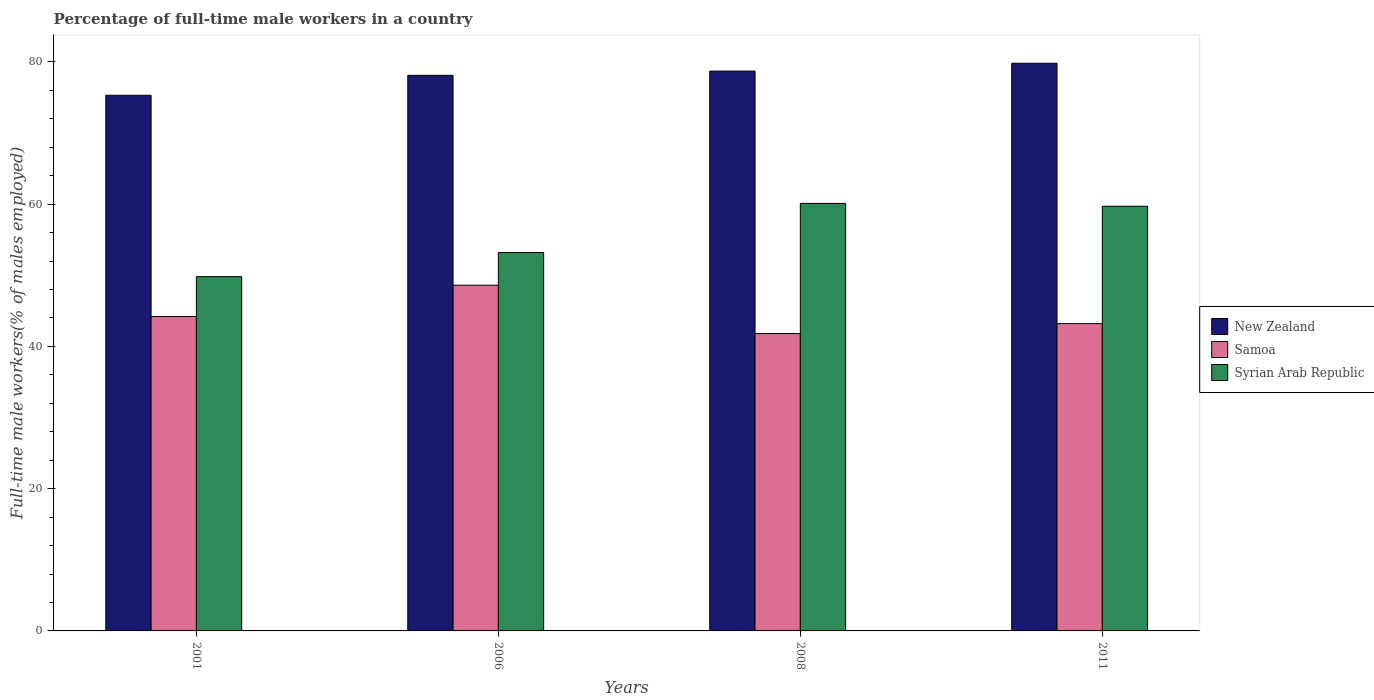Are the number of bars per tick equal to the number of legend labels?
Your answer should be very brief. Yes. Are the number of bars on each tick of the X-axis equal?
Offer a very short reply. Yes. How many bars are there on the 2nd tick from the right?
Ensure brevity in your answer.  3. What is the label of the 4th group of bars from the left?
Ensure brevity in your answer.  2011. What is the percentage of full-time male workers in New Zealand in 2011?
Provide a succinct answer. 79.8. Across all years, what is the maximum percentage of full-time male workers in New Zealand?
Offer a very short reply. 79.8. Across all years, what is the minimum percentage of full-time male workers in New Zealand?
Ensure brevity in your answer.  75.3. In which year was the percentage of full-time male workers in Syrian Arab Republic maximum?
Give a very brief answer. 2008. In which year was the percentage of full-time male workers in Syrian Arab Republic minimum?
Provide a short and direct response. 2001. What is the total percentage of full-time male workers in Syrian Arab Republic in the graph?
Offer a very short reply. 222.8. What is the difference between the percentage of full-time male workers in New Zealand in 2001 and that in 2006?
Make the answer very short. -2.8. What is the difference between the percentage of full-time male workers in Samoa in 2008 and the percentage of full-time male workers in New Zealand in 2011?
Ensure brevity in your answer.  -38. What is the average percentage of full-time male workers in Syrian Arab Republic per year?
Your response must be concise. 55.7. In the year 2001, what is the difference between the percentage of full-time male workers in Samoa and percentage of full-time male workers in New Zealand?
Your response must be concise. -31.1. In how many years, is the percentage of full-time male workers in Samoa greater than 32 %?
Your answer should be compact. 4. What is the ratio of the percentage of full-time male workers in New Zealand in 2001 to that in 2008?
Your response must be concise. 0.96. Is the difference between the percentage of full-time male workers in Samoa in 2006 and 2008 greater than the difference between the percentage of full-time male workers in New Zealand in 2006 and 2008?
Keep it short and to the point. Yes. What is the difference between the highest and the second highest percentage of full-time male workers in Syrian Arab Republic?
Provide a short and direct response. 0.4. What is the difference between the highest and the lowest percentage of full-time male workers in New Zealand?
Your answer should be very brief. 4.5. Is the sum of the percentage of full-time male workers in Syrian Arab Republic in 2001 and 2011 greater than the maximum percentage of full-time male workers in Samoa across all years?
Your answer should be compact. Yes. What does the 2nd bar from the left in 2008 represents?
Offer a terse response. Samoa. What does the 1st bar from the right in 2001 represents?
Offer a very short reply. Syrian Arab Republic. What is the difference between two consecutive major ticks on the Y-axis?
Your answer should be compact. 20. Are the values on the major ticks of Y-axis written in scientific E-notation?
Give a very brief answer. No. Does the graph contain grids?
Your answer should be very brief. No. Where does the legend appear in the graph?
Keep it short and to the point. Center right. How are the legend labels stacked?
Your answer should be compact. Vertical. What is the title of the graph?
Ensure brevity in your answer.  Percentage of full-time male workers in a country. What is the label or title of the X-axis?
Your response must be concise. Years. What is the label or title of the Y-axis?
Provide a succinct answer. Full-time male workers(% of males employed). What is the Full-time male workers(% of males employed) in New Zealand in 2001?
Give a very brief answer. 75.3. What is the Full-time male workers(% of males employed) in Samoa in 2001?
Provide a succinct answer. 44.2. What is the Full-time male workers(% of males employed) in Syrian Arab Republic in 2001?
Keep it short and to the point. 49.8. What is the Full-time male workers(% of males employed) of New Zealand in 2006?
Ensure brevity in your answer.  78.1. What is the Full-time male workers(% of males employed) in Samoa in 2006?
Offer a very short reply. 48.6. What is the Full-time male workers(% of males employed) in Syrian Arab Republic in 2006?
Provide a short and direct response. 53.2. What is the Full-time male workers(% of males employed) of New Zealand in 2008?
Keep it short and to the point. 78.7. What is the Full-time male workers(% of males employed) in Samoa in 2008?
Provide a succinct answer. 41.8. What is the Full-time male workers(% of males employed) of Syrian Arab Republic in 2008?
Make the answer very short. 60.1. What is the Full-time male workers(% of males employed) of New Zealand in 2011?
Give a very brief answer. 79.8. What is the Full-time male workers(% of males employed) of Samoa in 2011?
Provide a succinct answer. 43.2. What is the Full-time male workers(% of males employed) of Syrian Arab Republic in 2011?
Keep it short and to the point. 59.7. Across all years, what is the maximum Full-time male workers(% of males employed) in New Zealand?
Provide a short and direct response. 79.8. Across all years, what is the maximum Full-time male workers(% of males employed) in Samoa?
Make the answer very short. 48.6. Across all years, what is the maximum Full-time male workers(% of males employed) in Syrian Arab Republic?
Keep it short and to the point. 60.1. Across all years, what is the minimum Full-time male workers(% of males employed) in New Zealand?
Keep it short and to the point. 75.3. Across all years, what is the minimum Full-time male workers(% of males employed) in Samoa?
Provide a short and direct response. 41.8. Across all years, what is the minimum Full-time male workers(% of males employed) in Syrian Arab Republic?
Make the answer very short. 49.8. What is the total Full-time male workers(% of males employed) of New Zealand in the graph?
Your response must be concise. 311.9. What is the total Full-time male workers(% of males employed) of Samoa in the graph?
Offer a terse response. 177.8. What is the total Full-time male workers(% of males employed) in Syrian Arab Republic in the graph?
Provide a succinct answer. 222.8. What is the difference between the Full-time male workers(% of males employed) in Samoa in 2001 and that in 2006?
Your answer should be very brief. -4.4. What is the difference between the Full-time male workers(% of males employed) in Syrian Arab Republic in 2001 and that in 2006?
Offer a very short reply. -3.4. What is the difference between the Full-time male workers(% of males employed) of Samoa in 2001 and that in 2008?
Give a very brief answer. 2.4. What is the difference between the Full-time male workers(% of males employed) in Syrian Arab Republic in 2001 and that in 2011?
Keep it short and to the point. -9.9. What is the difference between the Full-time male workers(% of males employed) of Samoa in 2006 and that in 2008?
Your response must be concise. 6.8. What is the difference between the Full-time male workers(% of males employed) in Syrian Arab Republic in 2006 and that in 2008?
Your answer should be compact. -6.9. What is the difference between the Full-time male workers(% of males employed) in New Zealand in 2006 and that in 2011?
Provide a short and direct response. -1.7. What is the difference between the Full-time male workers(% of males employed) of Samoa in 2006 and that in 2011?
Your response must be concise. 5.4. What is the difference between the Full-time male workers(% of males employed) in Samoa in 2008 and that in 2011?
Offer a terse response. -1.4. What is the difference between the Full-time male workers(% of males employed) in New Zealand in 2001 and the Full-time male workers(% of males employed) in Samoa in 2006?
Ensure brevity in your answer.  26.7. What is the difference between the Full-time male workers(% of males employed) in New Zealand in 2001 and the Full-time male workers(% of males employed) in Syrian Arab Republic in 2006?
Keep it short and to the point. 22.1. What is the difference between the Full-time male workers(% of males employed) in Samoa in 2001 and the Full-time male workers(% of males employed) in Syrian Arab Republic in 2006?
Offer a terse response. -9. What is the difference between the Full-time male workers(% of males employed) of New Zealand in 2001 and the Full-time male workers(% of males employed) of Samoa in 2008?
Your answer should be compact. 33.5. What is the difference between the Full-time male workers(% of males employed) in Samoa in 2001 and the Full-time male workers(% of males employed) in Syrian Arab Republic in 2008?
Give a very brief answer. -15.9. What is the difference between the Full-time male workers(% of males employed) in New Zealand in 2001 and the Full-time male workers(% of males employed) in Samoa in 2011?
Ensure brevity in your answer.  32.1. What is the difference between the Full-time male workers(% of males employed) of Samoa in 2001 and the Full-time male workers(% of males employed) of Syrian Arab Republic in 2011?
Your response must be concise. -15.5. What is the difference between the Full-time male workers(% of males employed) in New Zealand in 2006 and the Full-time male workers(% of males employed) in Samoa in 2008?
Ensure brevity in your answer.  36.3. What is the difference between the Full-time male workers(% of males employed) of Samoa in 2006 and the Full-time male workers(% of males employed) of Syrian Arab Republic in 2008?
Your answer should be compact. -11.5. What is the difference between the Full-time male workers(% of males employed) in New Zealand in 2006 and the Full-time male workers(% of males employed) in Samoa in 2011?
Your answer should be compact. 34.9. What is the difference between the Full-time male workers(% of males employed) in Samoa in 2006 and the Full-time male workers(% of males employed) in Syrian Arab Republic in 2011?
Your response must be concise. -11.1. What is the difference between the Full-time male workers(% of males employed) in New Zealand in 2008 and the Full-time male workers(% of males employed) in Samoa in 2011?
Your response must be concise. 35.5. What is the difference between the Full-time male workers(% of males employed) in New Zealand in 2008 and the Full-time male workers(% of males employed) in Syrian Arab Republic in 2011?
Your answer should be very brief. 19. What is the difference between the Full-time male workers(% of males employed) in Samoa in 2008 and the Full-time male workers(% of males employed) in Syrian Arab Republic in 2011?
Your response must be concise. -17.9. What is the average Full-time male workers(% of males employed) in New Zealand per year?
Make the answer very short. 77.97. What is the average Full-time male workers(% of males employed) of Samoa per year?
Keep it short and to the point. 44.45. What is the average Full-time male workers(% of males employed) in Syrian Arab Republic per year?
Offer a very short reply. 55.7. In the year 2001, what is the difference between the Full-time male workers(% of males employed) of New Zealand and Full-time male workers(% of males employed) of Samoa?
Offer a very short reply. 31.1. In the year 2001, what is the difference between the Full-time male workers(% of males employed) of New Zealand and Full-time male workers(% of males employed) of Syrian Arab Republic?
Your answer should be very brief. 25.5. In the year 2001, what is the difference between the Full-time male workers(% of males employed) of Samoa and Full-time male workers(% of males employed) of Syrian Arab Republic?
Provide a succinct answer. -5.6. In the year 2006, what is the difference between the Full-time male workers(% of males employed) of New Zealand and Full-time male workers(% of males employed) of Samoa?
Your answer should be very brief. 29.5. In the year 2006, what is the difference between the Full-time male workers(% of males employed) in New Zealand and Full-time male workers(% of males employed) in Syrian Arab Republic?
Keep it short and to the point. 24.9. In the year 2006, what is the difference between the Full-time male workers(% of males employed) of Samoa and Full-time male workers(% of males employed) of Syrian Arab Republic?
Provide a short and direct response. -4.6. In the year 2008, what is the difference between the Full-time male workers(% of males employed) in New Zealand and Full-time male workers(% of males employed) in Samoa?
Ensure brevity in your answer.  36.9. In the year 2008, what is the difference between the Full-time male workers(% of males employed) in Samoa and Full-time male workers(% of males employed) in Syrian Arab Republic?
Give a very brief answer. -18.3. In the year 2011, what is the difference between the Full-time male workers(% of males employed) of New Zealand and Full-time male workers(% of males employed) of Samoa?
Provide a succinct answer. 36.6. In the year 2011, what is the difference between the Full-time male workers(% of males employed) in New Zealand and Full-time male workers(% of males employed) in Syrian Arab Republic?
Provide a succinct answer. 20.1. In the year 2011, what is the difference between the Full-time male workers(% of males employed) of Samoa and Full-time male workers(% of males employed) of Syrian Arab Republic?
Ensure brevity in your answer.  -16.5. What is the ratio of the Full-time male workers(% of males employed) in New Zealand in 2001 to that in 2006?
Make the answer very short. 0.96. What is the ratio of the Full-time male workers(% of males employed) in Samoa in 2001 to that in 2006?
Give a very brief answer. 0.91. What is the ratio of the Full-time male workers(% of males employed) of Syrian Arab Republic in 2001 to that in 2006?
Ensure brevity in your answer.  0.94. What is the ratio of the Full-time male workers(% of males employed) in New Zealand in 2001 to that in 2008?
Ensure brevity in your answer.  0.96. What is the ratio of the Full-time male workers(% of males employed) of Samoa in 2001 to that in 2008?
Your answer should be compact. 1.06. What is the ratio of the Full-time male workers(% of males employed) in Syrian Arab Republic in 2001 to that in 2008?
Make the answer very short. 0.83. What is the ratio of the Full-time male workers(% of males employed) in New Zealand in 2001 to that in 2011?
Keep it short and to the point. 0.94. What is the ratio of the Full-time male workers(% of males employed) in Samoa in 2001 to that in 2011?
Offer a very short reply. 1.02. What is the ratio of the Full-time male workers(% of males employed) of Syrian Arab Republic in 2001 to that in 2011?
Provide a succinct answer. 0.83. What is the ratio of the Full-time male workers(% of males employed) in New Zealand in 2006 to that in 2008?
Provide a short and direct response. 0.99. What is the ratio of the Full-time male workers(% of males employed) in Samoa in 2006 to that in 2008?
Ensure brevity in your answer.  1.16. What is the ratio of the Full-time male workers(% of males employed) in Syrian Arab Republic in 2006 to that in 2008?
Give a very brief answer. 0.89. What is the ratio of the Full-time male workers(% of males employed) of New Zealand in 2006 to that in 2011?
Keep it short and to the point. 0.98. What is the ratio of the Full-time male workers(% of males employed) of Samoa in 2006 to that in 2011?
Your response must be concise. 1.12. What is the ratio of the Full-time male workers(% of males employed) in Syrian Arab Republic in 2006 to that in 2011?
Ensure brevity in your answer.  0.89. What is the ratio of the Full-time male workers(% of males employed) in New Zealand in 2008 to that in 2011?
Your response must be concise. 0.99. What is the ratio of the Full-time male workers(% of males employed) in Samoa in 2008 to that in 2011?
Offer a very short reply. 0.97. What is the ratio of the Full-time male workers(% of males employed) of Syrian Arab Republic in 2008 to that in 2011?
Your answer should be compact. 1.01. What is the difference between the highest and the second highest Full-time male workers(% of males employed) in Samoa?
Your response must be concise. 4.4. What is the difference between the highest and the lowest Full-time male workers(% of males employed) in Samoa?
Provide a short and direct response. 6.8. What is the difference between the highest and the lowest Full-time male workers(% of males employed) in Syrian Arab Republic?
Make the answer very short. 10.3. 